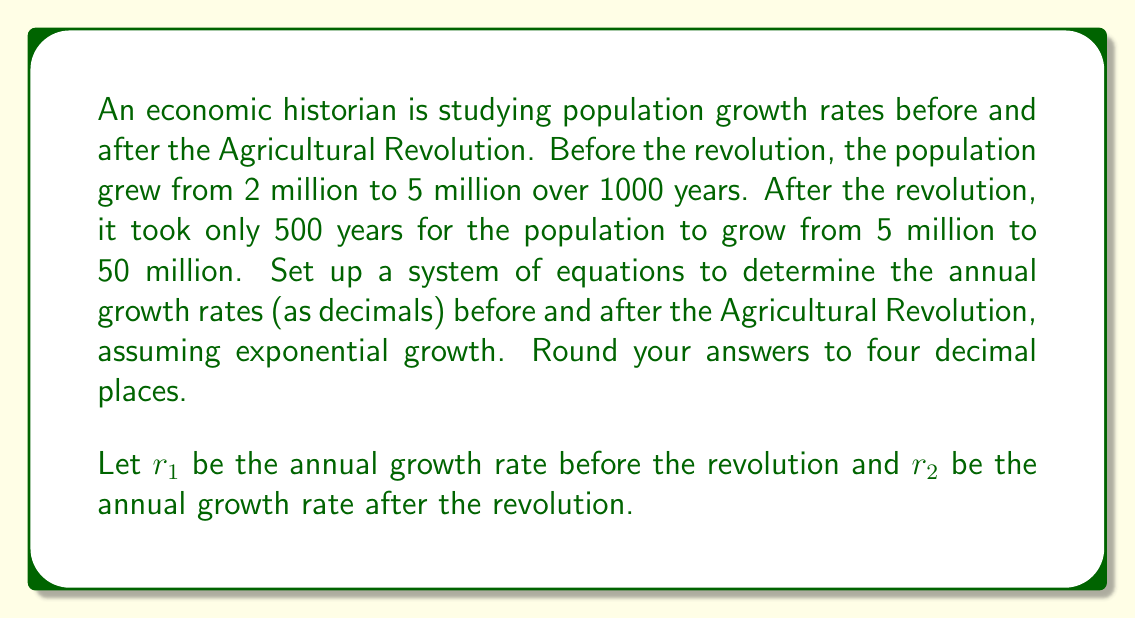Can you answer this question? 1. Set up the exponential growth equation for the period before the Agricultural Revolution:
   $$5,000,000 = 2,000,000 \cdot (1 + r_1)^{1000}$$

2. Set up the exponential growth equation for the period after the Agricultural Revolution:
   $$50,000,000 = 5,000,000 \cdot (1 + r_2)^{500}$$

3. Simplify the first equation:
   $$2.5 = (1 + r_1)^{1000}$$
   $$\sqrt[1000]{2.5} = 1 + r_1$$
   $$r_1 = \sqrt[1000]{2.5} - 1 \approx 0.0009$$

4. Simplify the second equation:
   $$10 = (1 + r_2)^{500}$$
   $$\sqrt[500]{10} = 1 + r_2$$
   $$r_2 = \sqrt[500]{10} - 1 \approx 0.0047$$

5. Round both results to four decimal places:
   $r_1 \approx 0.0009$
   $r_2 \approx 0.0047$
Answer: Before: 0.0009, After: 0.0047 